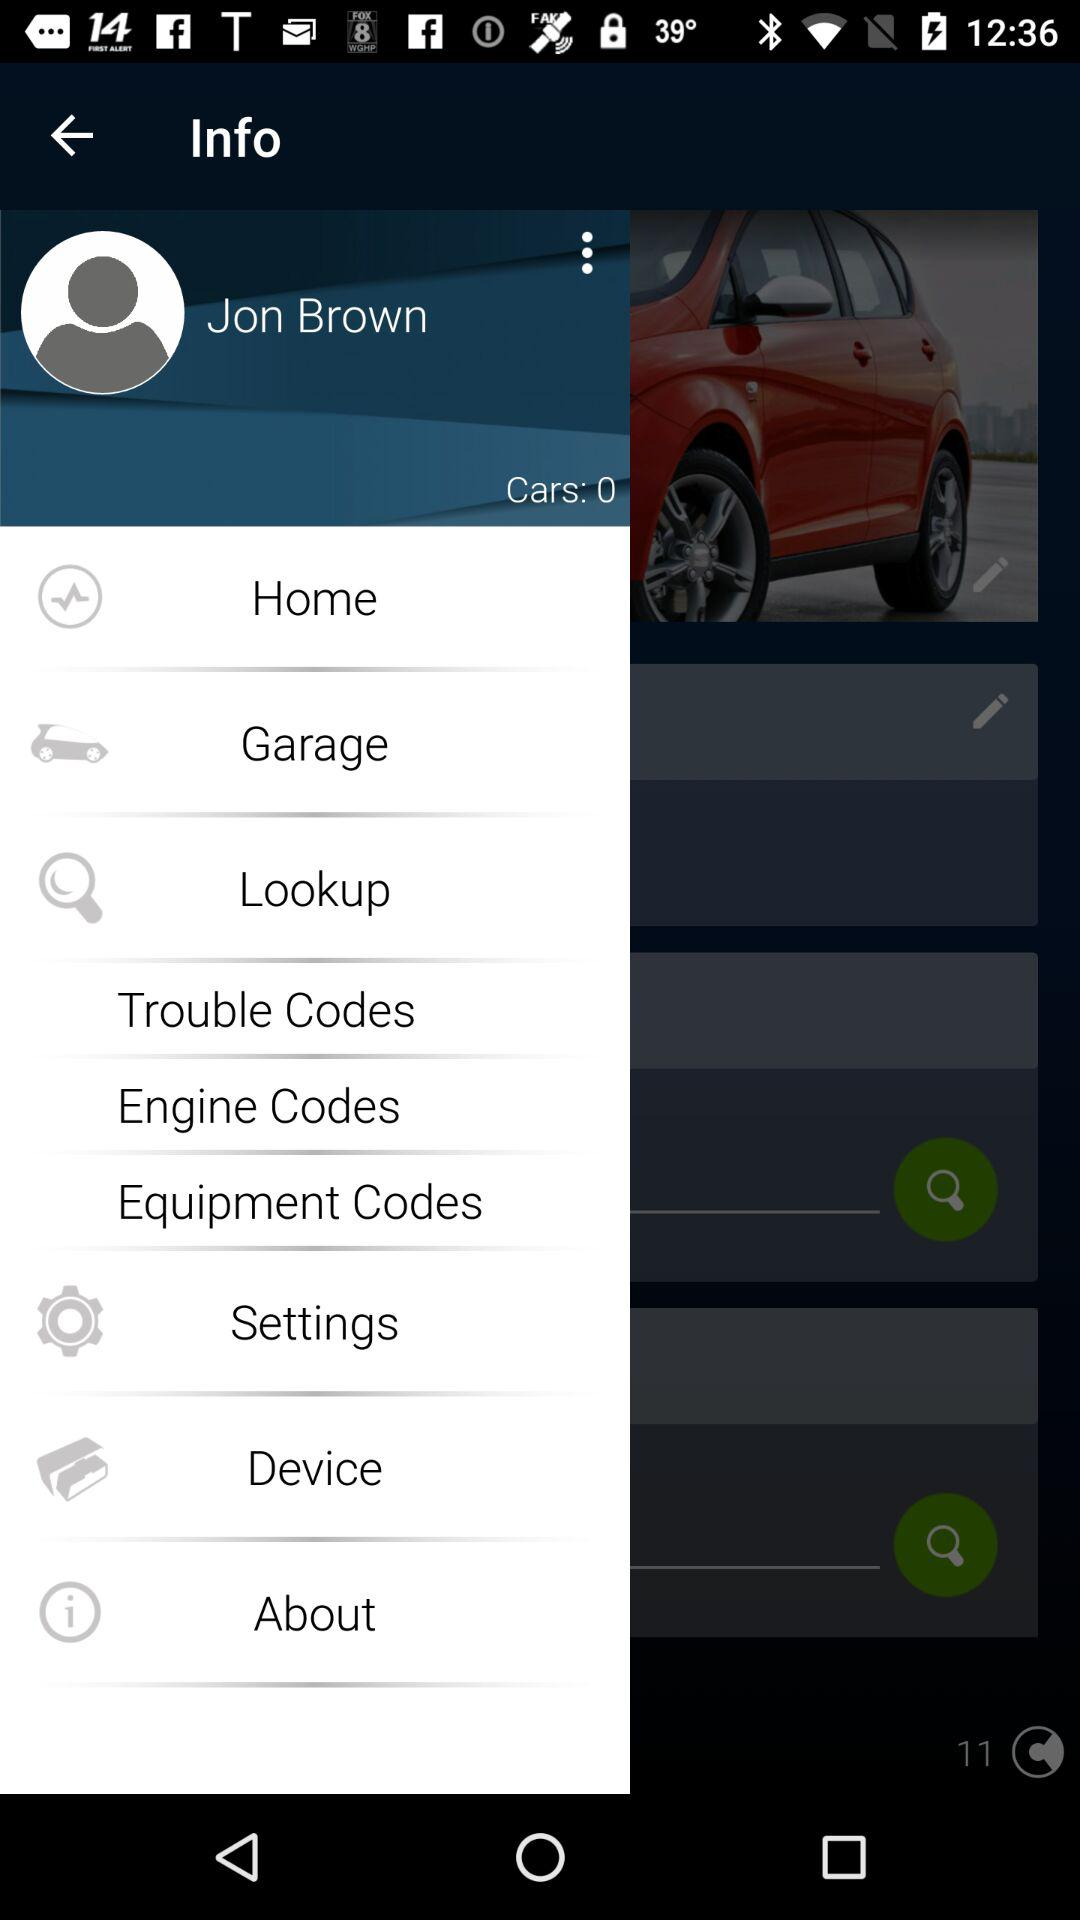What is the count of the cars shown? The count of the cars shown is 0. 